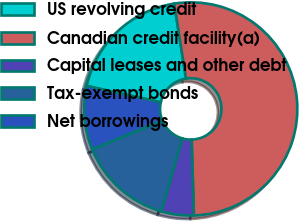Convert chart to OTSL. <chart><loc_0><loc_0><loc_500><loc_500><pie_chart><fcel>US revolving credit<fcel>Canadian credit facility(a)<fcel>Capital leases and other debt<fcel>Tax-exempt bonds<fcel>Net borrowings<nl><fcel>19.06%<fcel>52.02%<fcel>4.93%<fcel>14.35%<fcel>9.64%<nl></chart> 